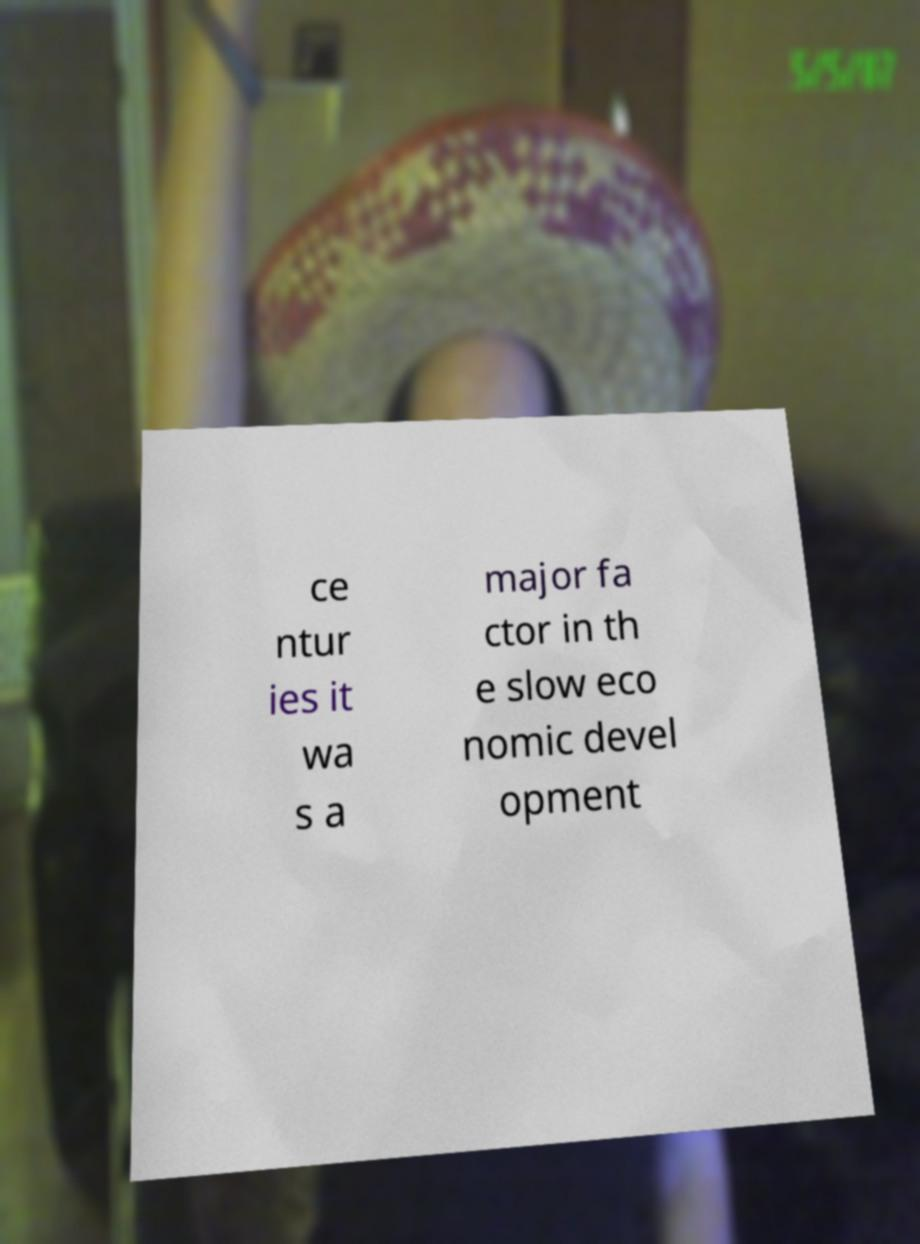What messages or text are displayed in this image? I need them in a readable, typed format. ce ntur ies it wa s a major fa ctor in th e slow eco nomic devel opment 